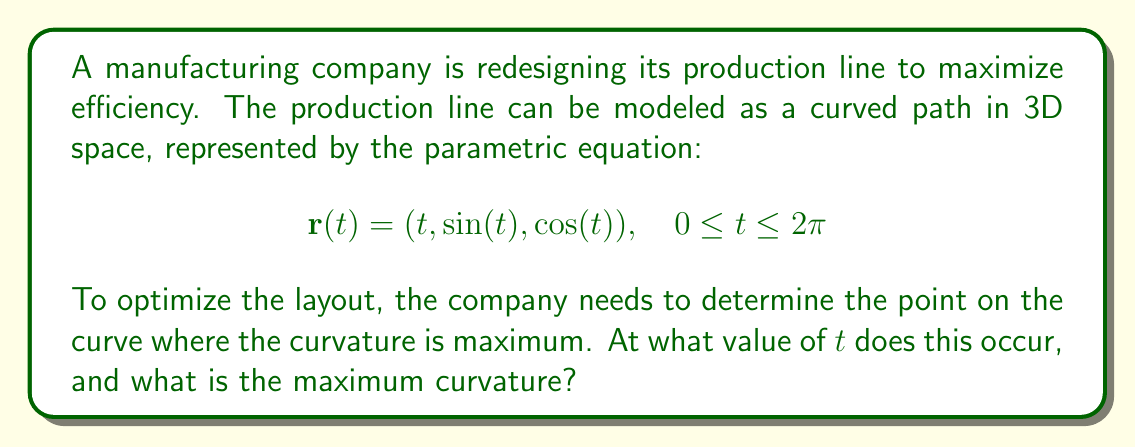Show me your answer to this math problem. To solve this problem, we'll follow these steps:

1) First, we need to calculate the curvature formula. For a parametric curve, the curvature $\kappa$ is given by:

   $$\kappa = \frac{|\mathbf{r}'(t) \times \mathbf{r}''(t)|}{|\mathbf{r}'(t)|^3}$$

2) Calculate $\mathbf{r}'(t)$:
   $$\mathbf{r}'(t) = (1, \cos(t), -\sin(t))$$

3) Calculate $\mathbf{r}''(t)$:
   $$\mathbf{r}''(t) = (0, -\sin(t), -\cos(t))$$

4) Calculate $\mathbf{r}'(t) \times \mathbf{r}''(t)$:
   $$\mathbf{r}'(t) \times \mathbf{r}''(t) = (\cos^2(t) + \sin^2(t), \sin(t), \cos(t)) = (1, \sin(t), \cos(t))$$

5) Calculate $|\mathbf{r}'(t) \times \mathbf{r}''(t)|$:
   $$|\mathbf{r}'(t) \times \mathbf{r}''(t)| = \sqrt{1 + \sin^2(t) + \cos^2(t)} = \sqrt{2}$$

6) Calculate $|\mathbf{r}'(t)|$:
   $$|\mathbf{r}'(t)| = \sqrt{1 + \cos^2(t) + \sin^2(t)} = \sqrt{2}$$

7) Now we can write the curvature formula:

   $$\kappa = \frac{\sqrt{2}}{(\sqrt{2})^3} = \frac{1}{2}$$

8) We see that the curvature is constant and equal to $\frac{1}{2}$ for all values of $t$. This means the maximum curvature occurs at all points on the curve.
Answer: Maximum curvature $\frac{1}{2}$ occurs at all $t \in [0, 2\pi]$ 